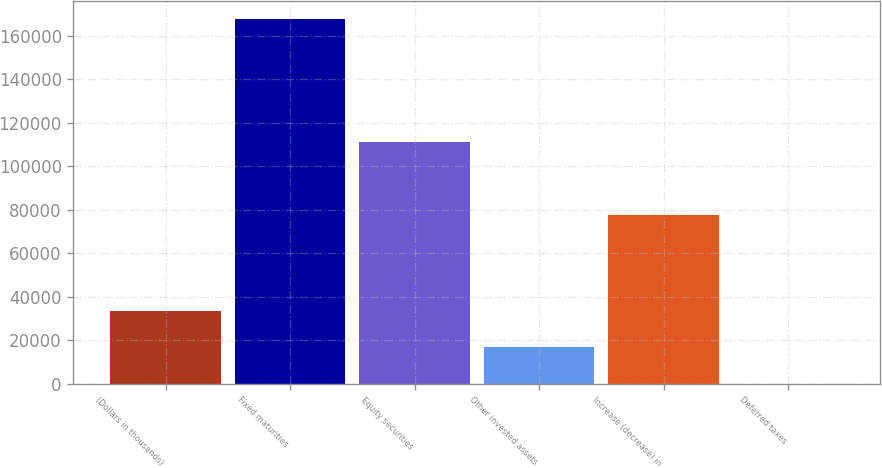<chart> <loc_0><loc_0><loc_500><loc_500><bar_chart><fcel>(Dollars in thousands)<fcel>Fixed maturities<fcel>Equity securities<fcel>Other invested assets<fcel>Increase (decrease) in<fcel>Deferred taxes<nl><fcel>33556.8<fcel>167660<fcel>111282<fcel>16793.9<fcel>77756<fcel>31<nl></chart> 